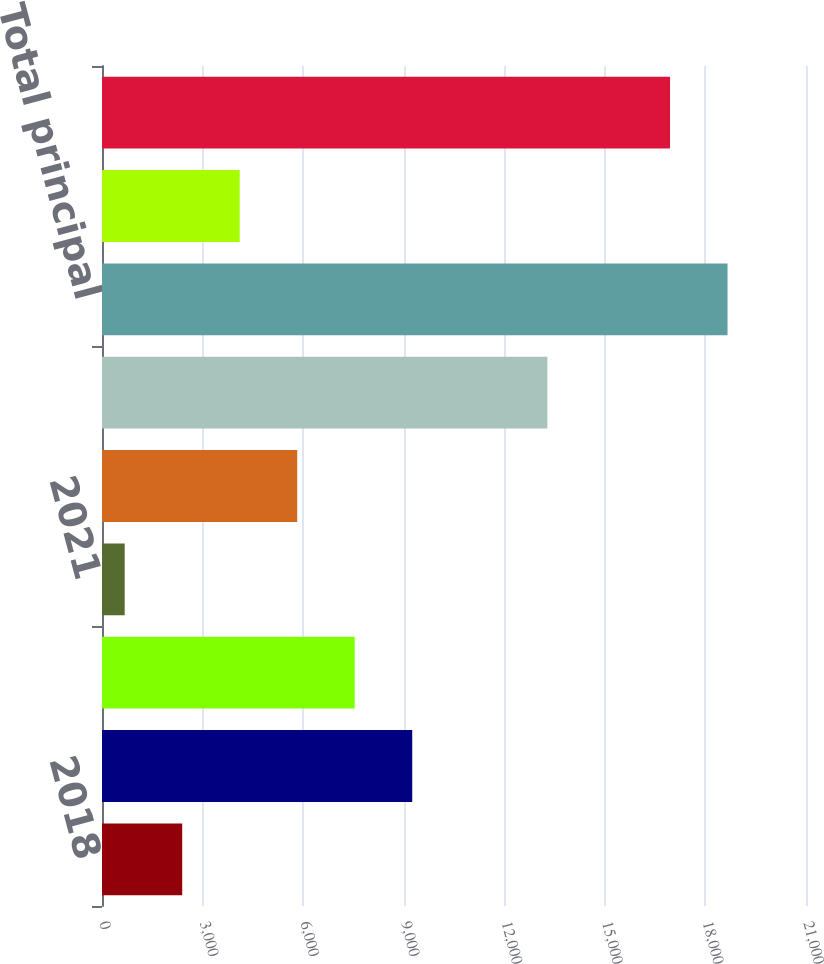Convert chart. <chart><loc_0><loc_0><loc_500><loc_500><bar_chart><fcel>2018<fcel>2019<fcel>2020<fcel>2021<fcel>2022<fcel>Thereafter<fcel>Total principal<fcel>Unamortized discount and<fcel>Total debt<nl><fcel>2392.4<fcel>9254<fcel>7538.6<fcel>677<fcel>5823.2<fcel>13285<fcel>18659.4<fcel>4107.8<fcel>16944<nl></chart> 